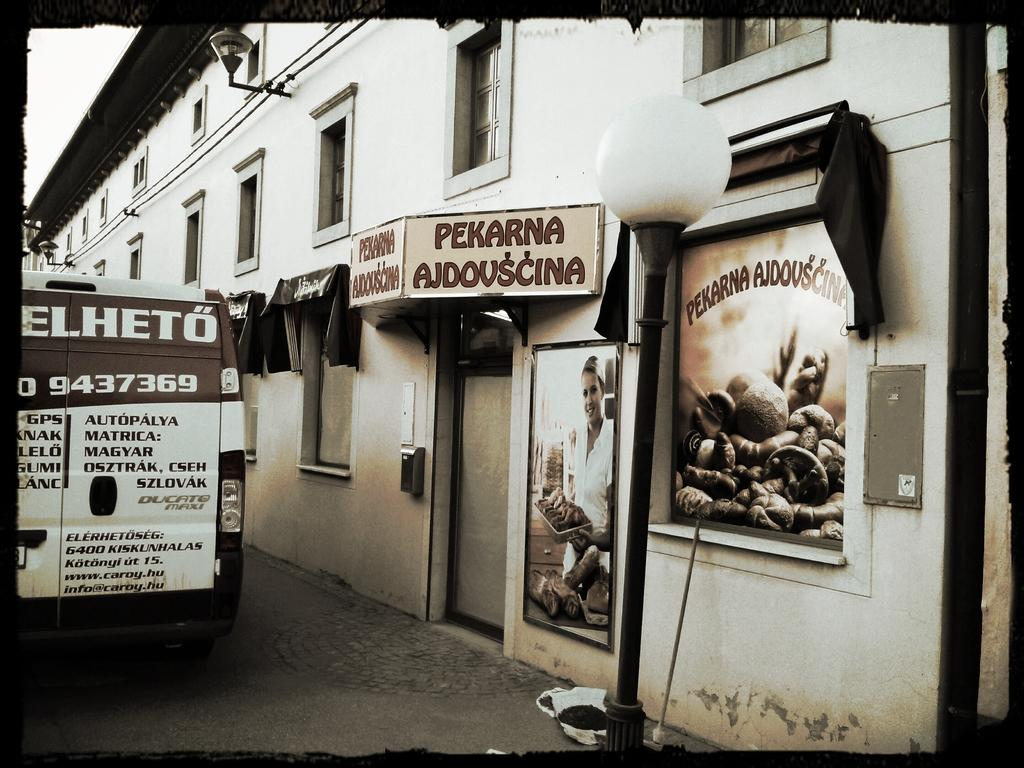<image>
Describe the image concisely. white van with 9437369 on the back parked in front of pekarna ajdovscina 